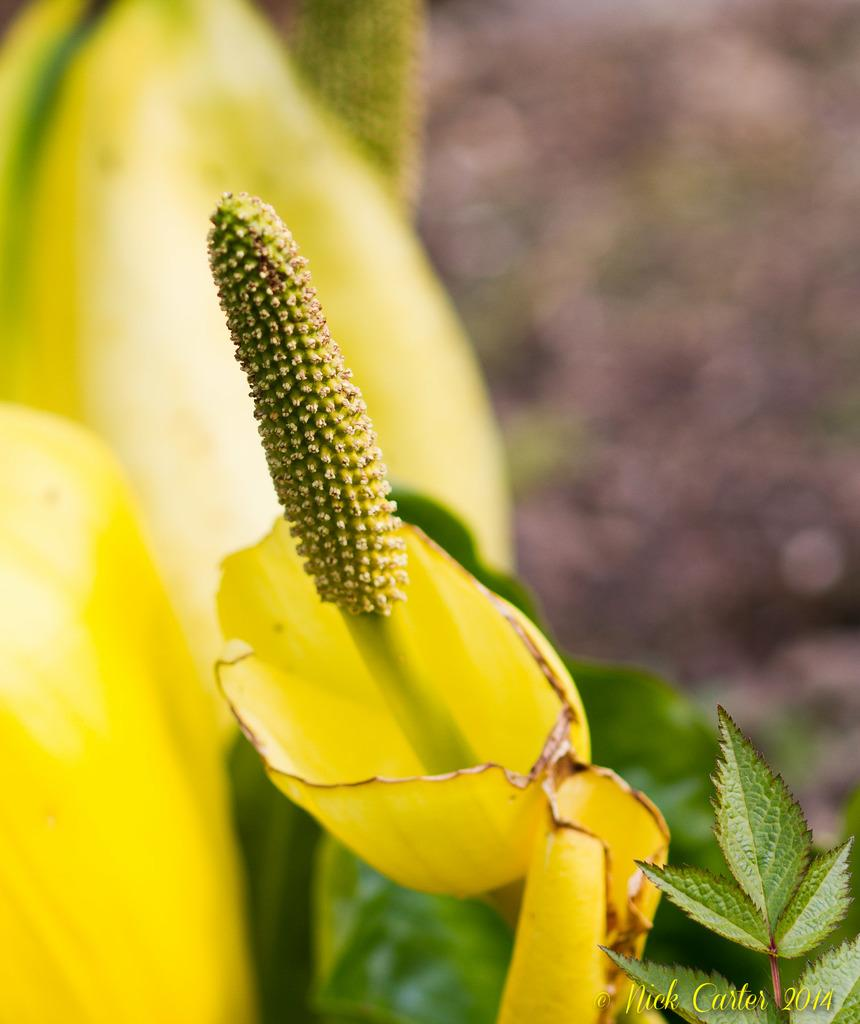What is the main subject in the center of the image? There is a plant in the center of the image. What feature of the plant is highlighted? The plant has flowers. What color are the flowers? The flowers are yellow. Where can text be found in the image? The text is in the bottom right side of the image. Can you hear the thunder in the image? There is no thunder present in the image, as it is a still image of a plant with yellow flowers. 